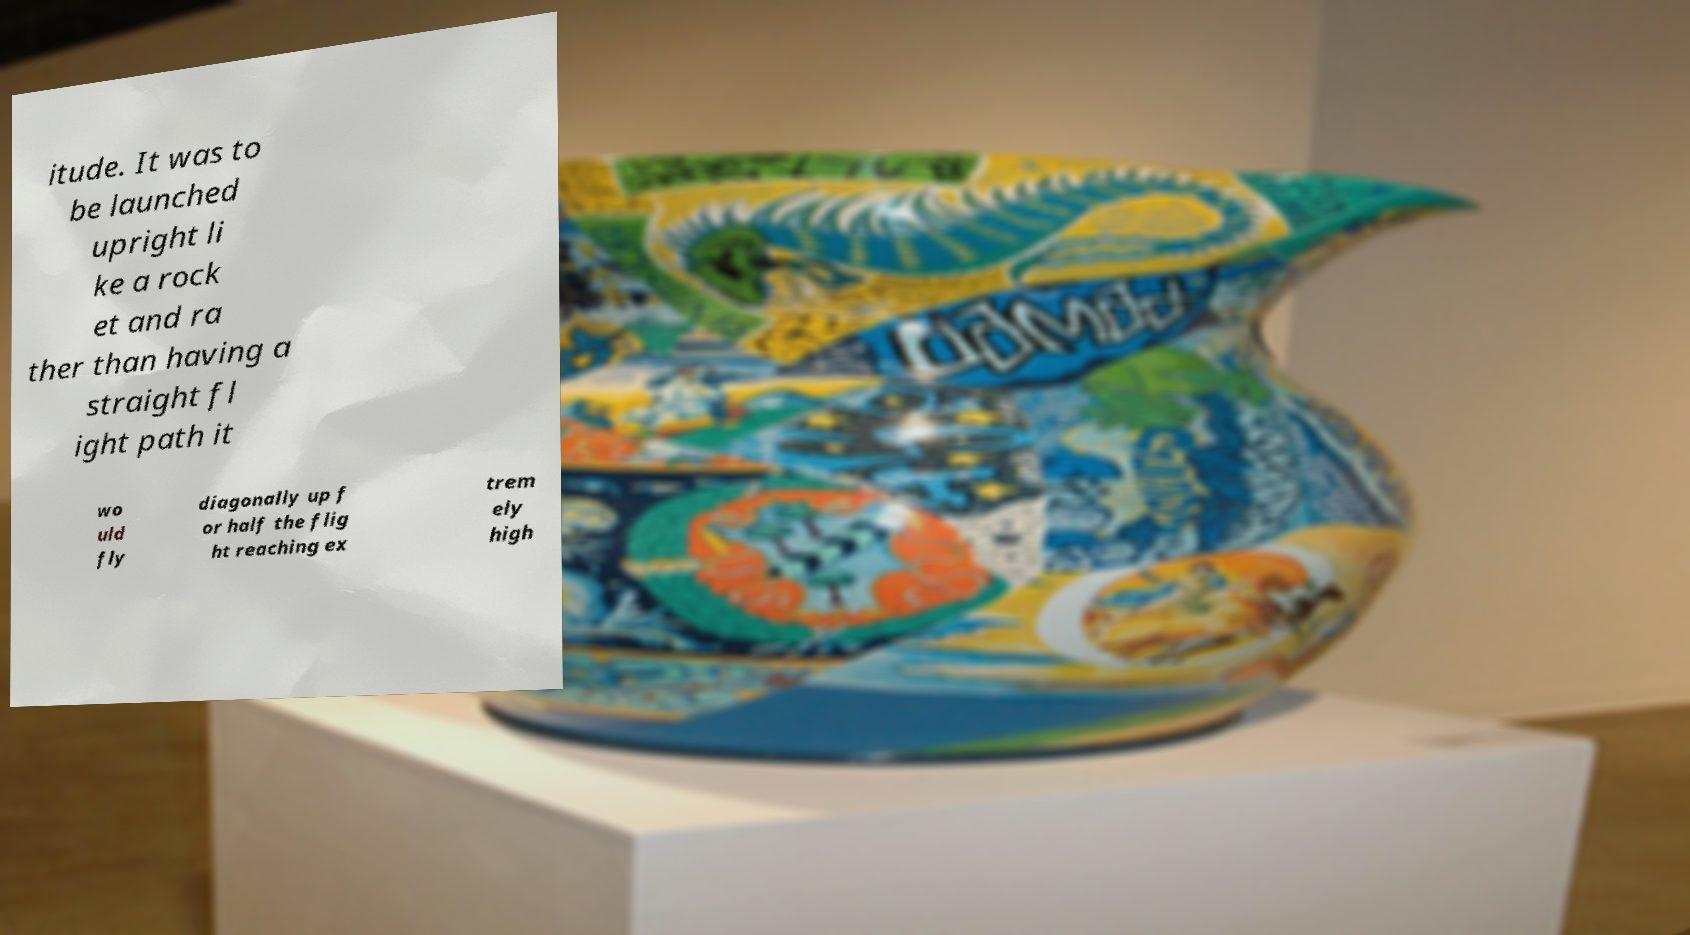There's text embedded in this image that I need extracted. Can you transcribe it verbatim? itude. It was to be launched upright li ke a rock et and ra ther than having a straight fl ight path it wo uld fly diagonally up f or half the flig ht reaching ex trem ely high 